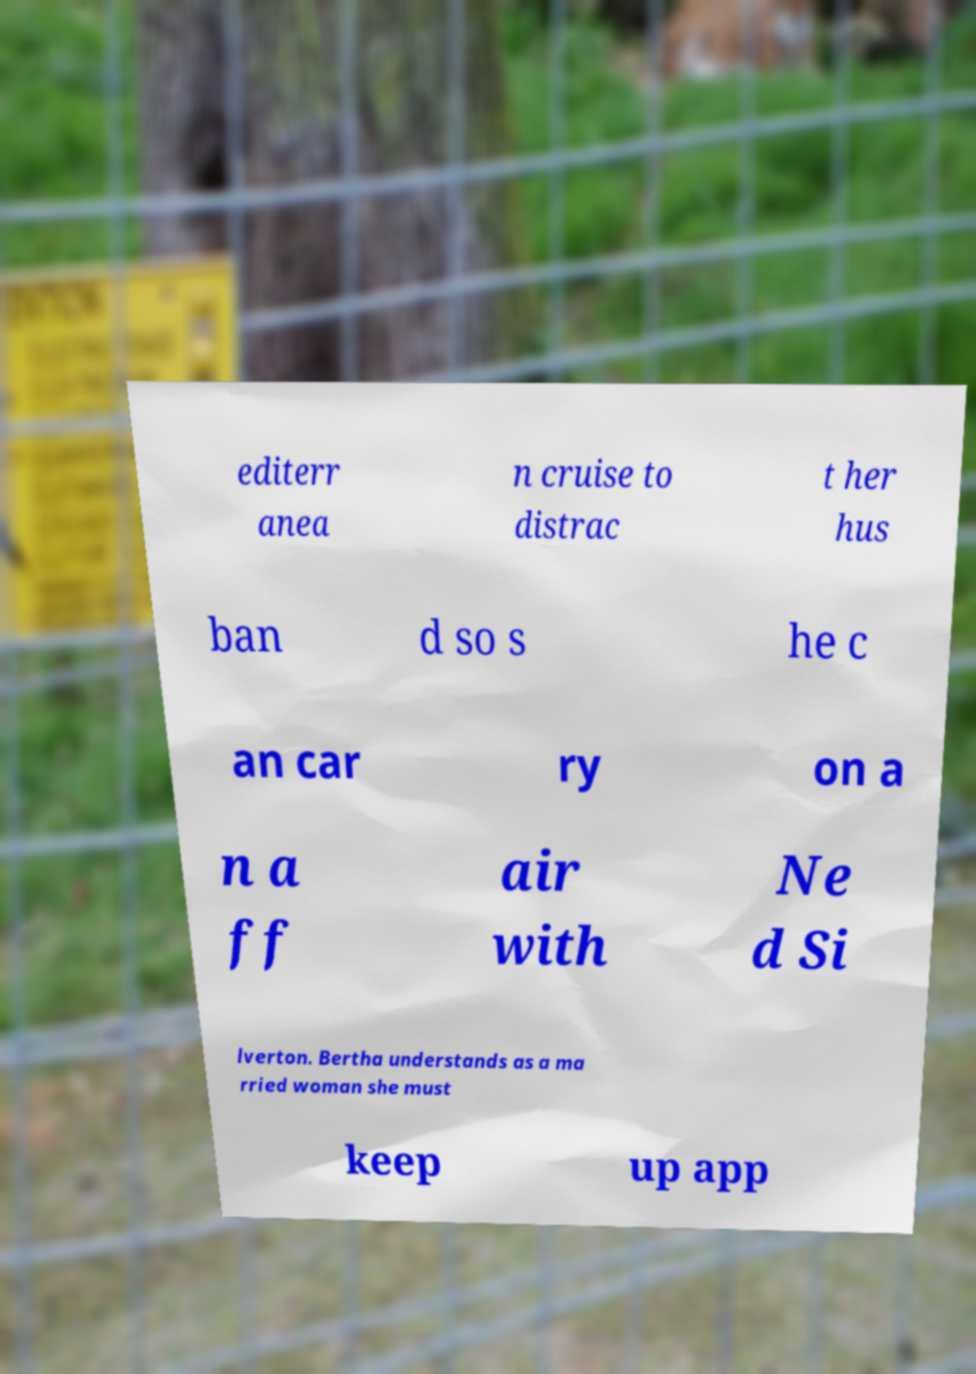For documentation purposes, I need the text within this image transcribed. Could you provide that? editerr anea n cruise to distrac t her hus ban d so s he c an car ry on a n a ff air with Ne d Si lverton. Bertha understands as a ma rried woman she must keep up app 